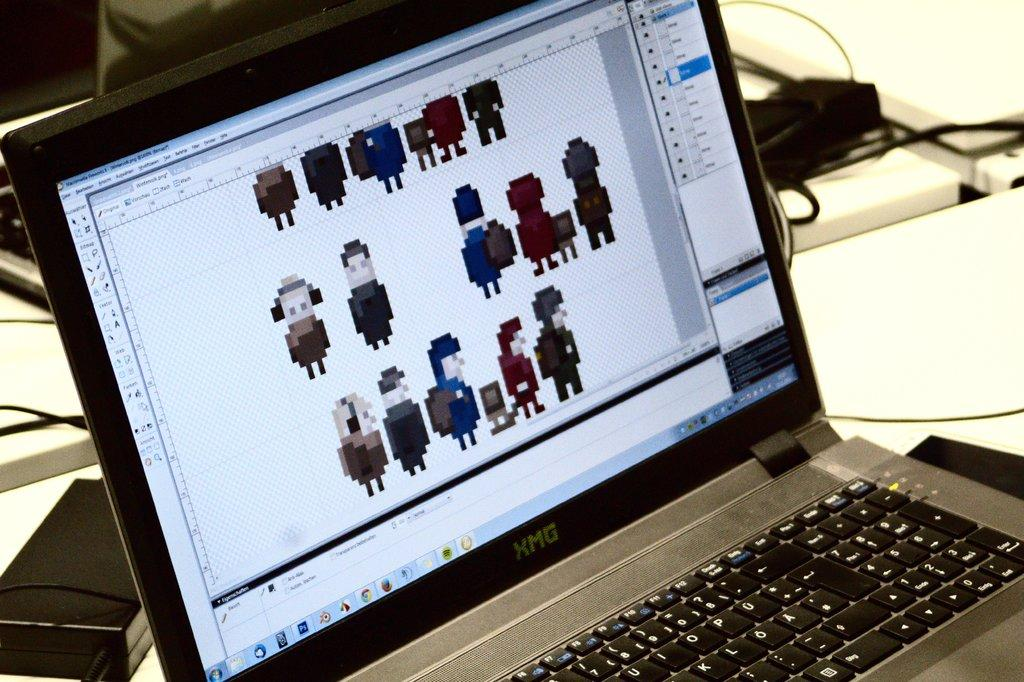<image>
Describe the image concisely. An open laptop with the letters XMG below the screen. 